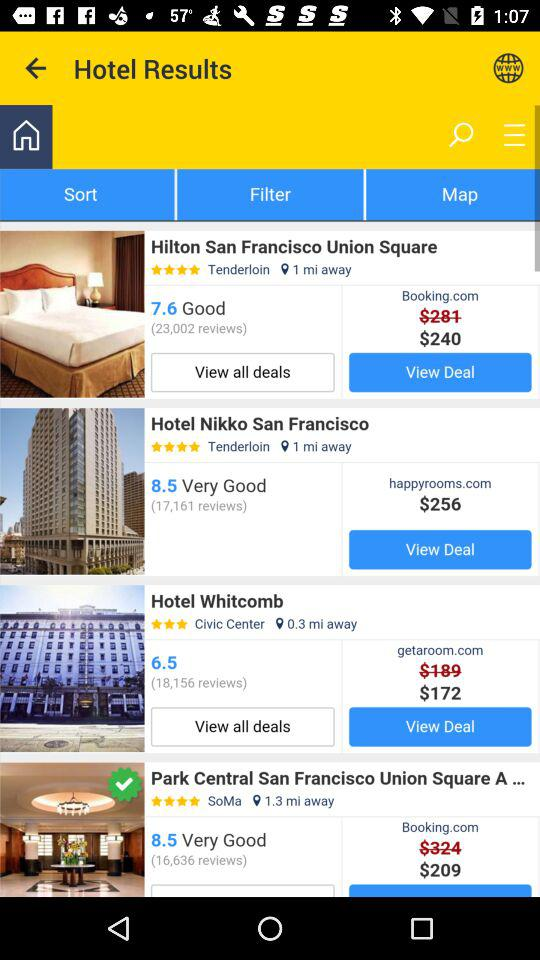What is the rating of Hotel Whitcomb? The rating is 3 stars. 